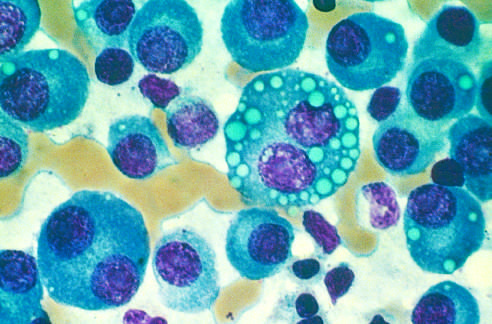what are normal marrow cells cells replaced by?
Answer the question using a single word or phrase. Plasma cells 